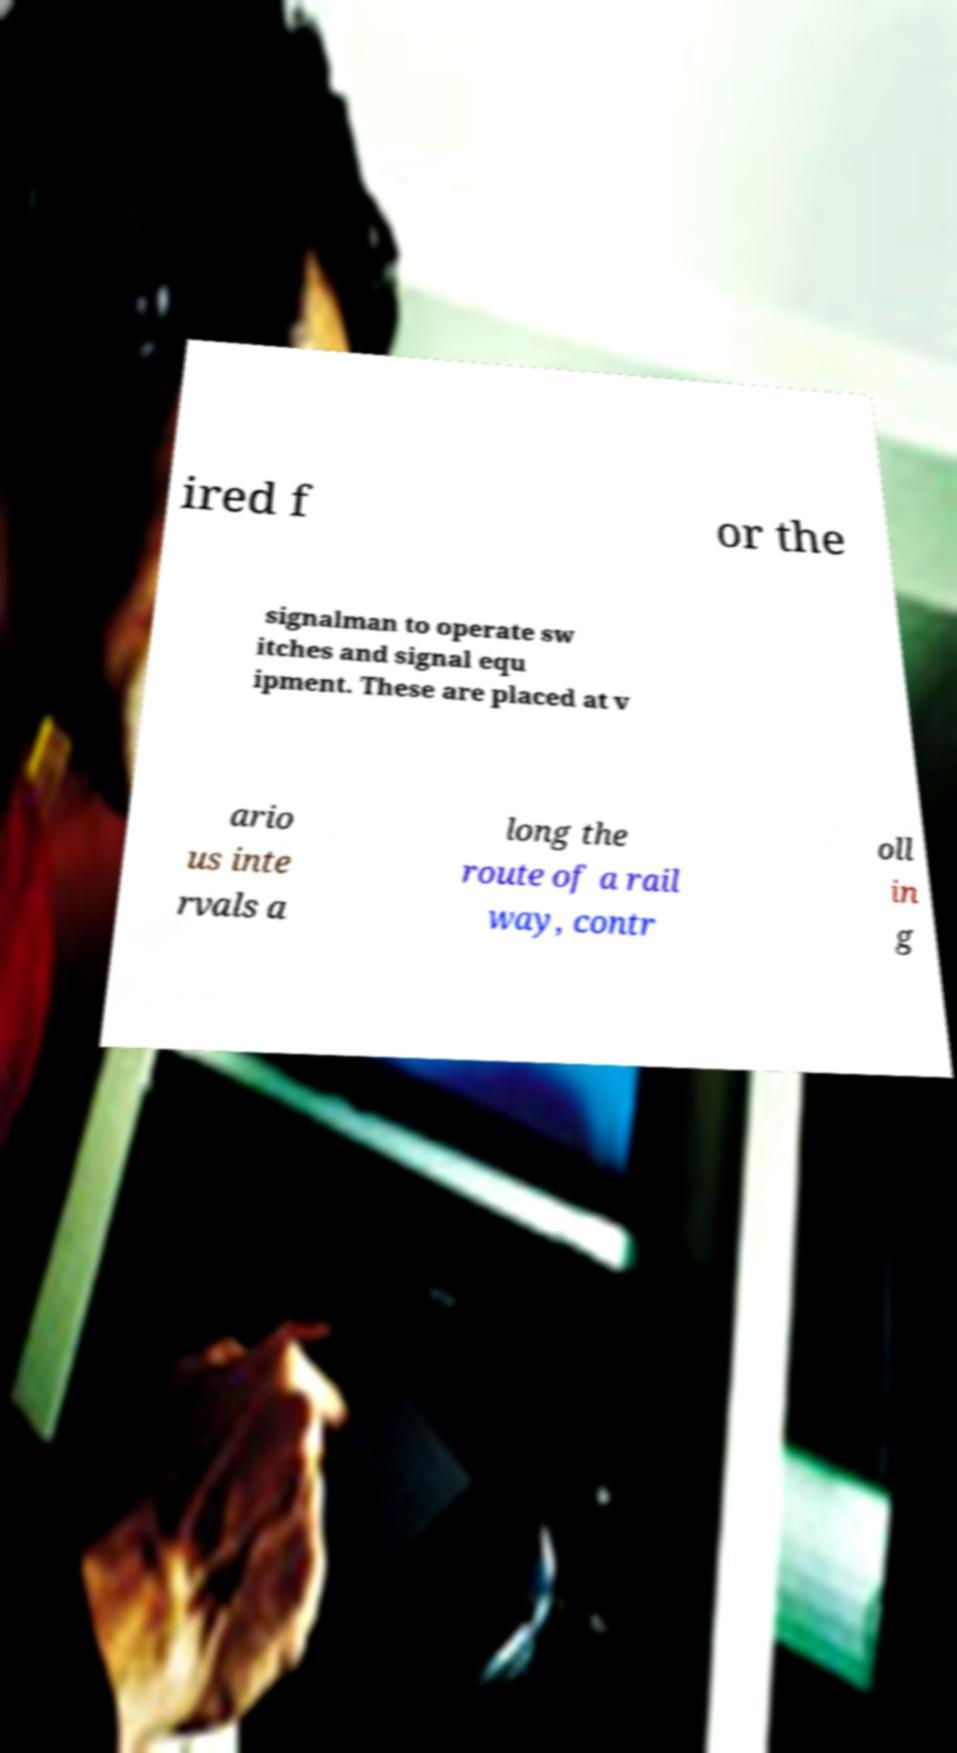Could you assist in decoding the text presented in this image and type it out clearly? ired f or the signalman to operate sw itches and signal equ ipment. These are placed at v ario us inte rvals a long the route of a rail way, contr oll in g 